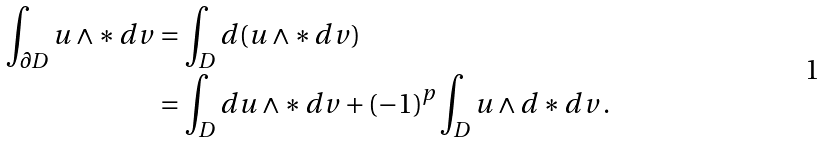<formula> <loc_0><loc_0><loc_500><loc_500>\int _ { \partial D } u \wedge \ast \, d v & = \int _ { D } d ( u \wedge \ast \, d v ) \\ & = \int _ { D } d u \wedge \ast \, d v + ( - 1 ) ^ { p } \int _ { D } u \wedge d \ast d v \, .</formula> 